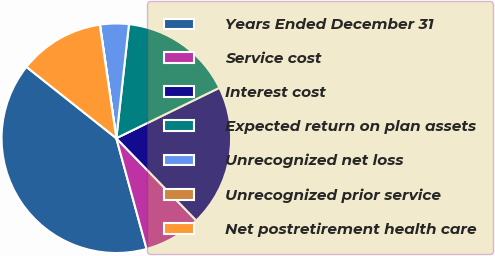Convert chart. <chart><loc_0><loc_0><loc_500><loc_500><pie_chart><fcel>Years Ended December 31<fcel>Service cost<fcel>Interest cost<fcel>Expected return on plan assets<fcel>Unrecognized net loss<fcel>Unrecognized prior service<fcel>Net postretirement health care<nl><fcel>39.93%<fcel>8.02%<fcel>19.98%<fcel>16.0%<fcel>4.03%<fcel>0.04%<fcel>12.01%<nl></chart> 